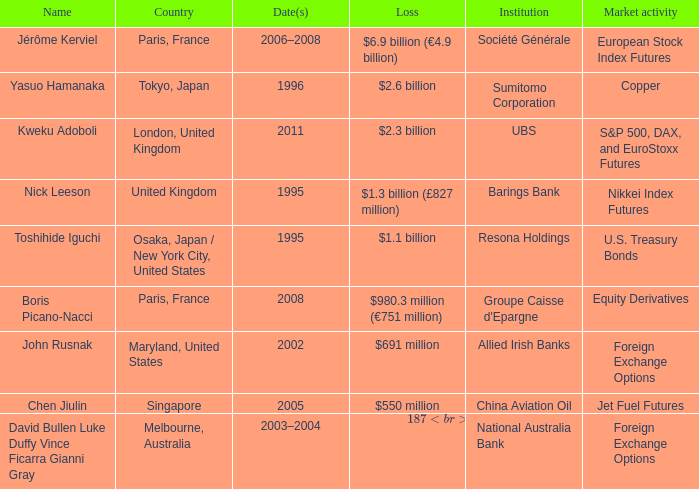What was the loss for Boris Picano-Nacci? $980.3 million (€751 million). 